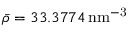Convert formula to latex. <formula><loc_0><loc_0><loc_500><loc_500>\bar { \rho } = 3 3 . 3 7 7 4 \, n m ^ { - 3 }</formula> 